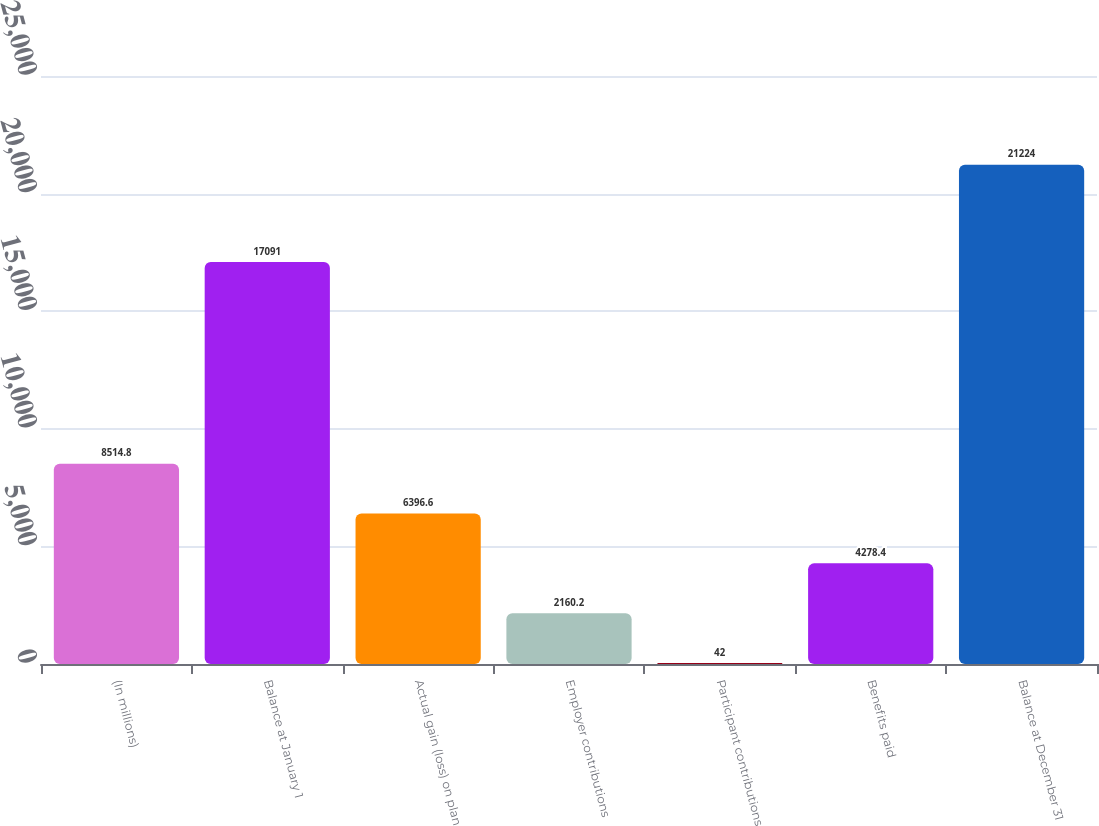<chart> <loc_0><loc_0><loc_500><loc_500><bar_chart><fcel>(In millions)<fcel>Balance at January 1<fcel>Actual gain (loss) on plan<fcel>Employer contributions<fcel>Participant contributions<fcel>Benefits paid<fcel>Balance at December 31<nl><fcel>8514.8<fcel>17091<fcel>6396.6<fcel>2160.2<fcel>42<fcel>4278.4<fcel>21224<nl></chart> 